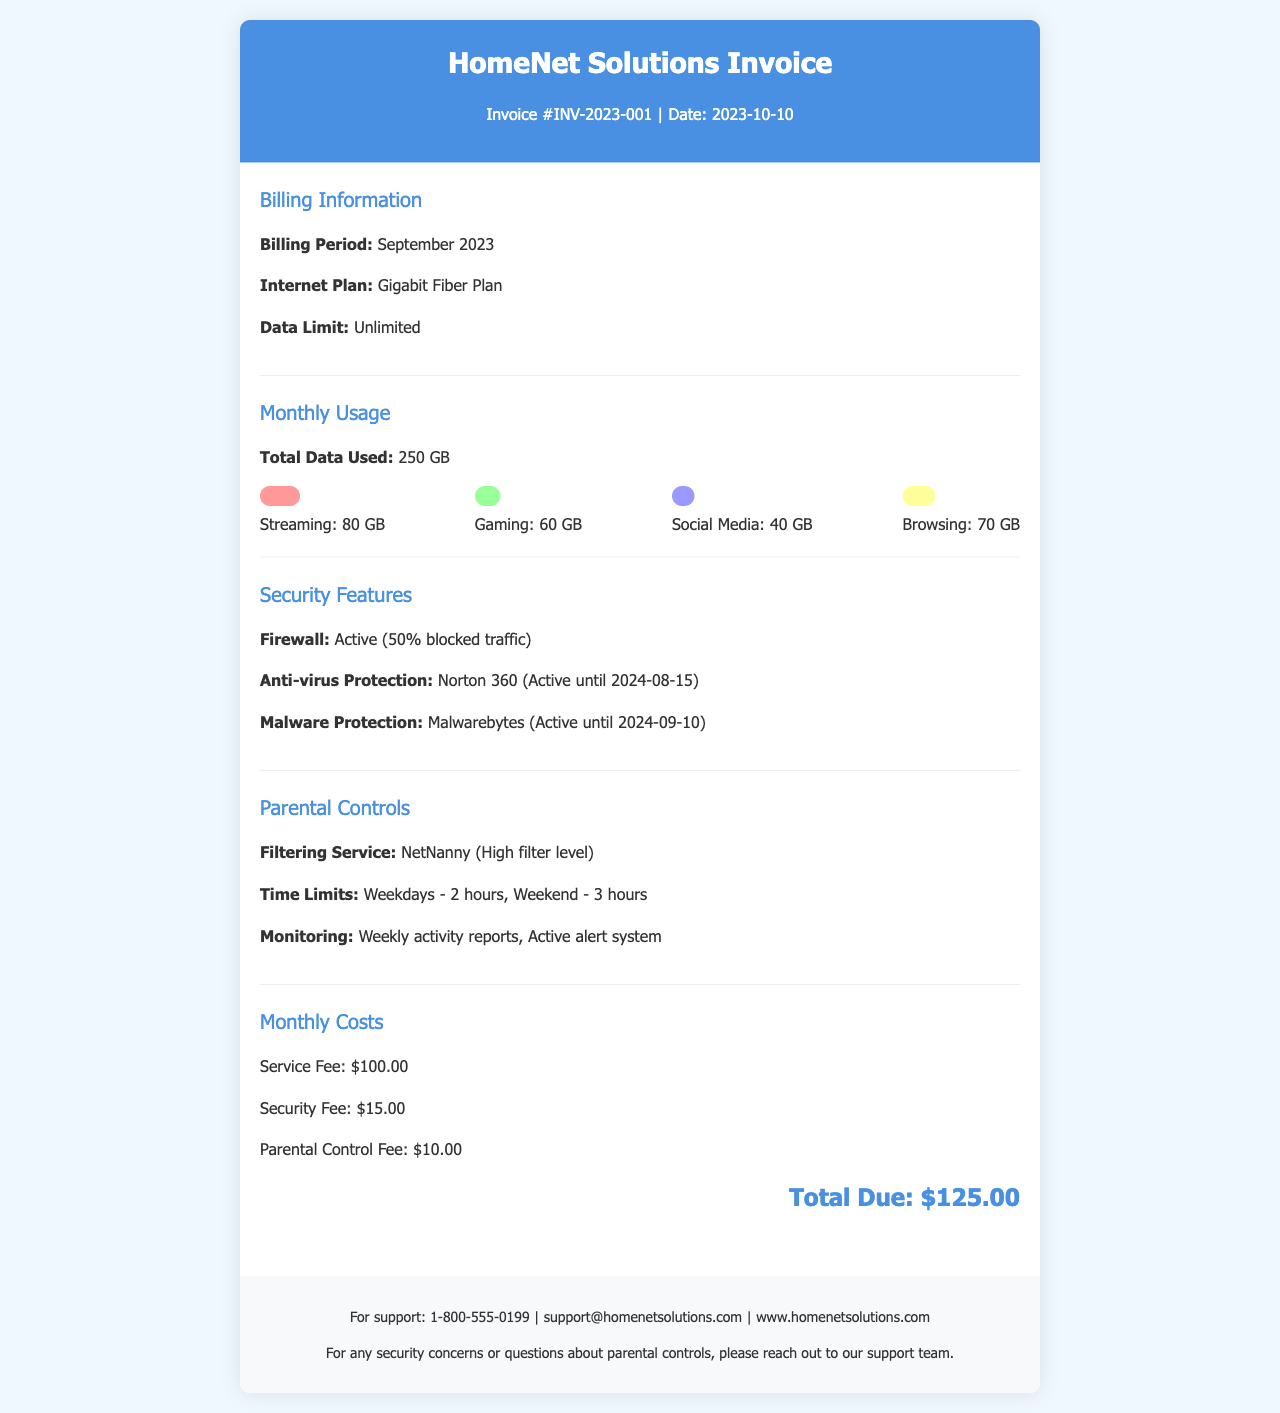what is the invoice number? The invoice number is stated prominently at the top of the document as INV-2023-001.
Answer: INV-2023-001 what is the billing period? The billing period mentioned in the document is September 2023.
Answer: September 2023 how much total data was used? The document specifies that the total data used was 250 GB.
Answer: 250 GB what is the active anti-virus protection? The active anti-virus protection mentioned is Norton 360, which is effective until a specific date.
Answer: Norton 360 what is the fee for parental controls? The parental control fee is detailed in the monthly costs section of the document as $10.00.
Answer: $10.00 how many hours are allowed on weekends? The document states that weekends allow for a total of 3 hours of usage under the parental controls.
Answer: 3 hours what filtering service is used? The filtering service noted in the document is NetNanny, specified as having a high filter level.
Answer: NetNanny when does the anti-virus protection expire? The expiration date for the anti-virus protection is indicated as August 15, 2024.
Answer: 2024-08-15 what is the total amount due? The total amount due is calculated and shown at the end of the document as $125.00.
Answer: $125.00 